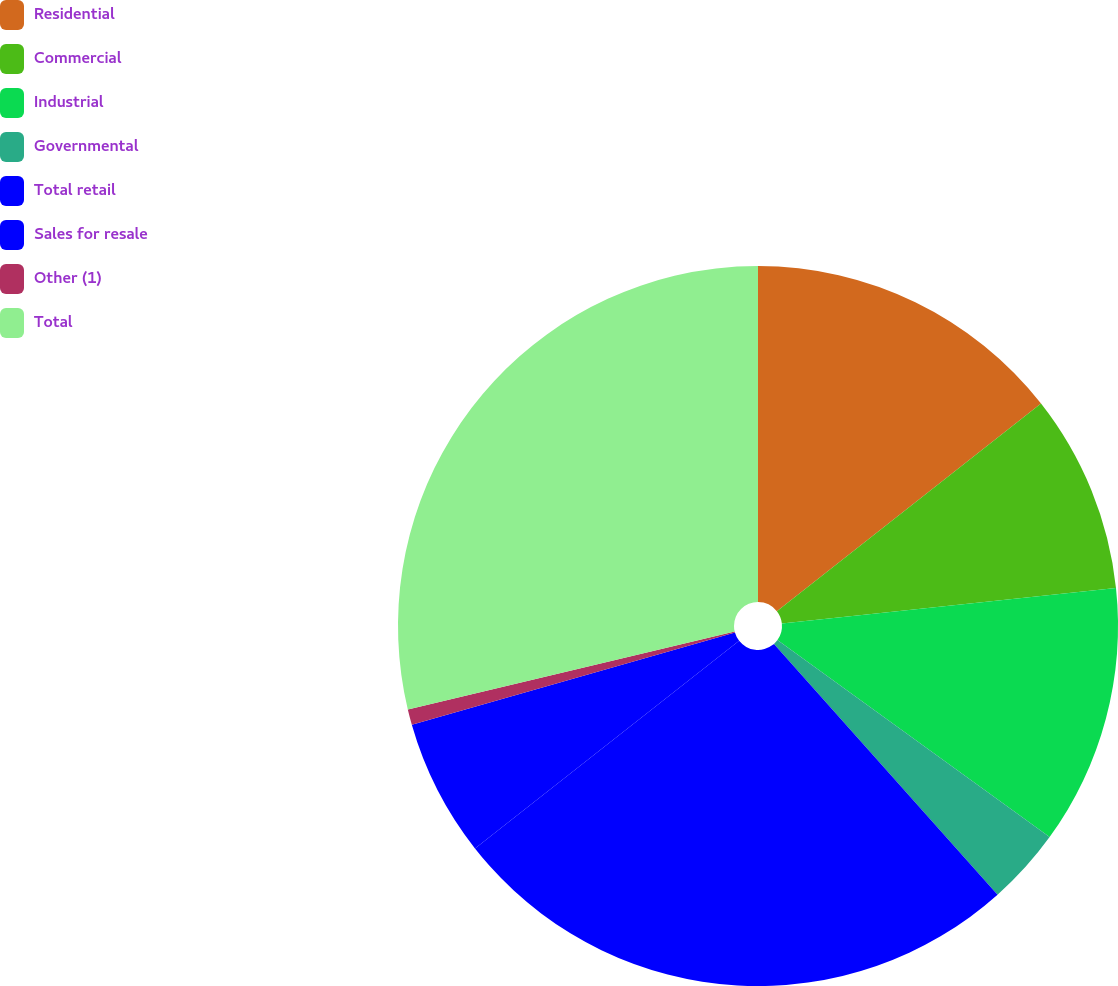<chart> <loc_0><loc_0><loc_500><loc_500><pie_chart><fcel>Residential<fcel>Commercial<fcel>Industrial<fcel>Governmental<fcel>Total retail<fcel>Sales for resale<fcel>Other (1)<fcel>Total<nl><fcel>14.4%<fcel>8.92%<fcel>11.66%<fcel>3.44%<fcel>25.99%<fcel>6.18%<fcel>0.7%<fcel>28.73%<nl></chart> 